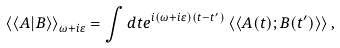Convert formula to latex. <formula><loc_0><loc_0><loc_500><loc_500>\left \langle \left \langle A | B \right \rangle \right \rangle _ { \omega + i \varepsilon } = \int d t e ^ { i ( \omega + i \varepsilon ) ( t - t ^ { \prime } ) } \left \langle \left \langle A ( t ) ; B ( t ^ { \prime } ) \right \rangle \right \rangle ,</formula> 